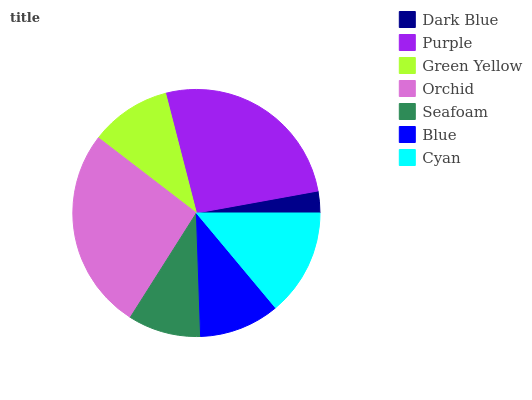Is Dark Blue the minimum?
Answer yes or no. Yes. Is Orchid the maximum?
Answer yes or no. Yes. Is Purple the minimum?
Answer yes or no. No. Is Purple the maximum?
Answer yes or no. No. Is Purple greater than Dark Blue?
Answer yes or no. Yes. Is Dark Blue less than Purple?
Answer yes or no. Yes. Is Dark Blue greater than Purple?
Answer yes or no. No. Is Purple less than Dark Blue?
Answer yes or no. No. Is Green Yellow the high median?
Answer yes or no. Yes. Is Green Yellow the low median?
Answer yes or no. Yes. Is Blue the high median?
Answer yes or no. No. Is Blue the low median?
Answer yes or no. No. 